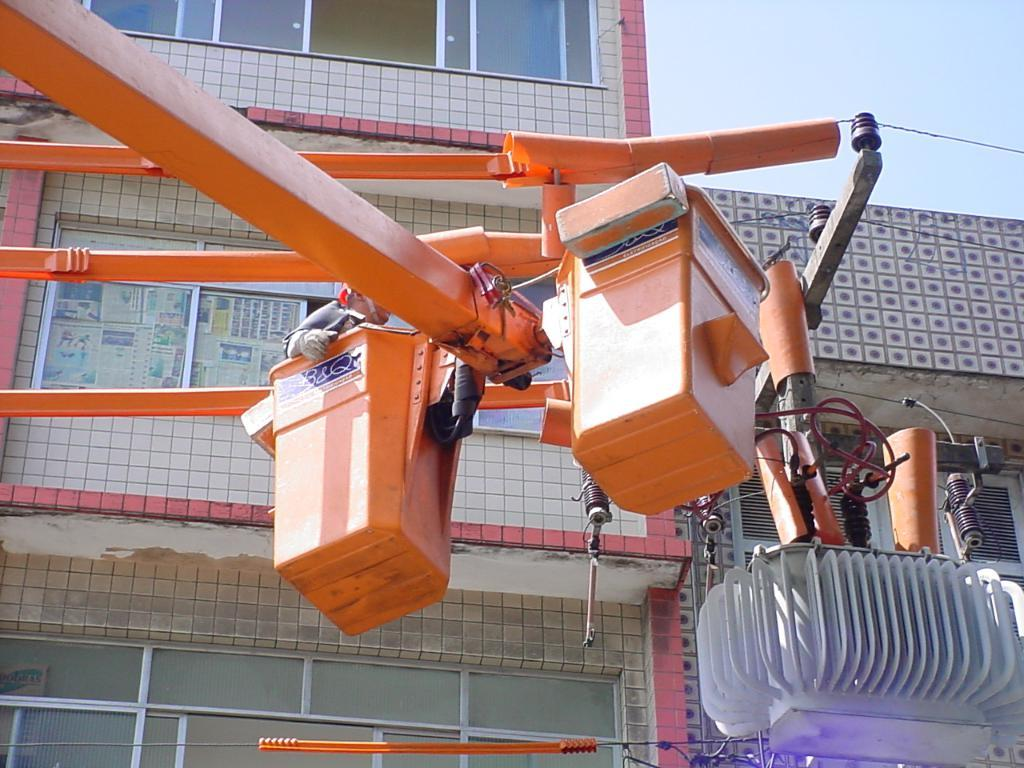What is the main subject in the foreground of the image? There is a machine in the foreground of the image. What can be seen behind the machine in the image? There is a building behind the machine in the image. What type of art can be seen on the hands of the person wearing a mask in the image? There is no person wearing a mask or any art present in the image; it only features a machine and a building. 